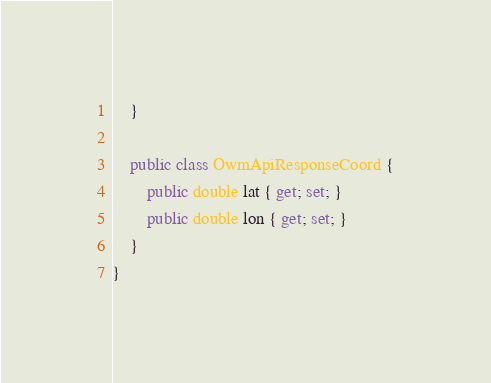<code> <loc_0><loc_0><loc_500><loc_500><_C#_>    }

    public class OwmApiResponseCoord {
        public double lat { get; set; }
        public double lon { get; set; }
    }
}</code> 